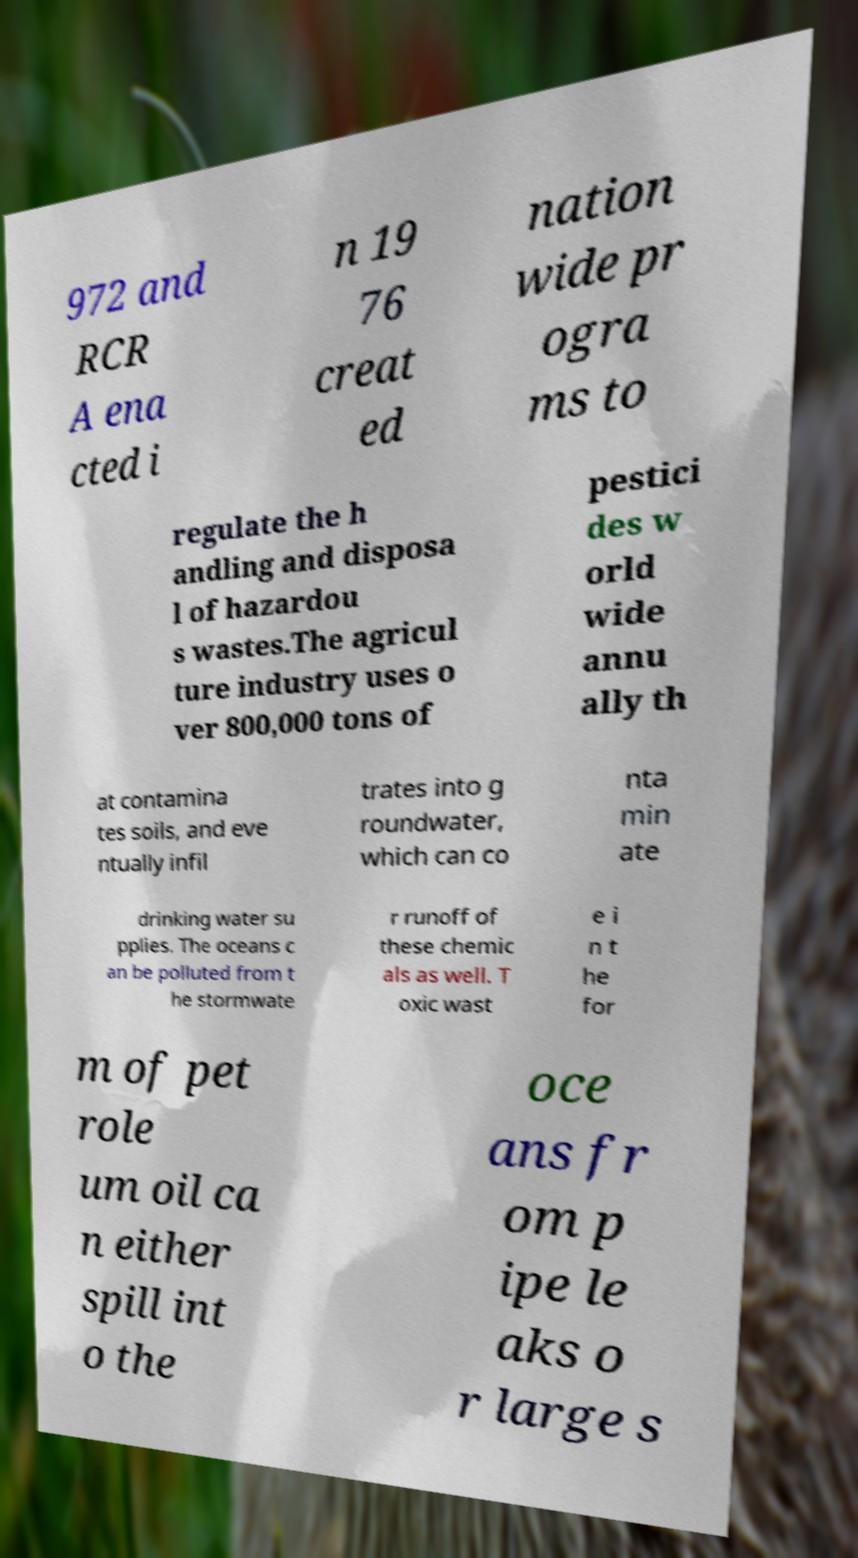For documentation purposes, I need the text within this image transcribed. Could you provide that? 972 and RCR A ena cted i n 19 76 creat ed nation wide pr ogra ms to regulate the h andling and disposa l of hazardou s wastes.The agricul ture industry uses o ver 800,000 tons of pestici des w orld wide annu ally th at contamina tes soils, and eve ntually infil trates into g roundwater, which can co nta min ate drinking water su pplies. The oceans c an be polluted from t he stormwate r runoff of these chemic als as well. T oxic wast e i n t he for m of pet role um oil ca n either spill int o the oce ans fr om p ipe le aks o r large s 